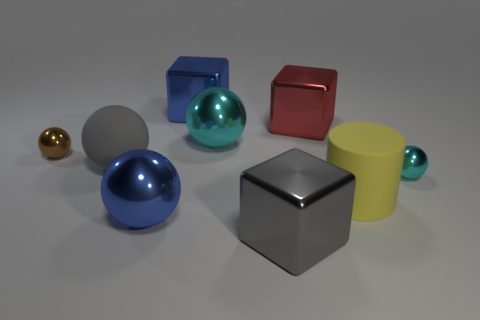Subtract all brown cylinders. How many cyan spheres are left? 2 Subtract all small brown metal spheres. How many spheres are left? 4 Subtract all cyan spheres. How many spheres are left? 3 Subtract all cubes. How many objects are left? 6 Subtract all green blocks. Subtract all purple balls. How many blocks are left? 3 Add 3 brown things. How many brown things exist? 4 Subtract 0 green blocks. How many objects are left? 9 Subtract all big rubber things. Subtract all small cyan spheres. How many objects are left? 6 Add 3 big gray things. How many big gray things are left? 5 